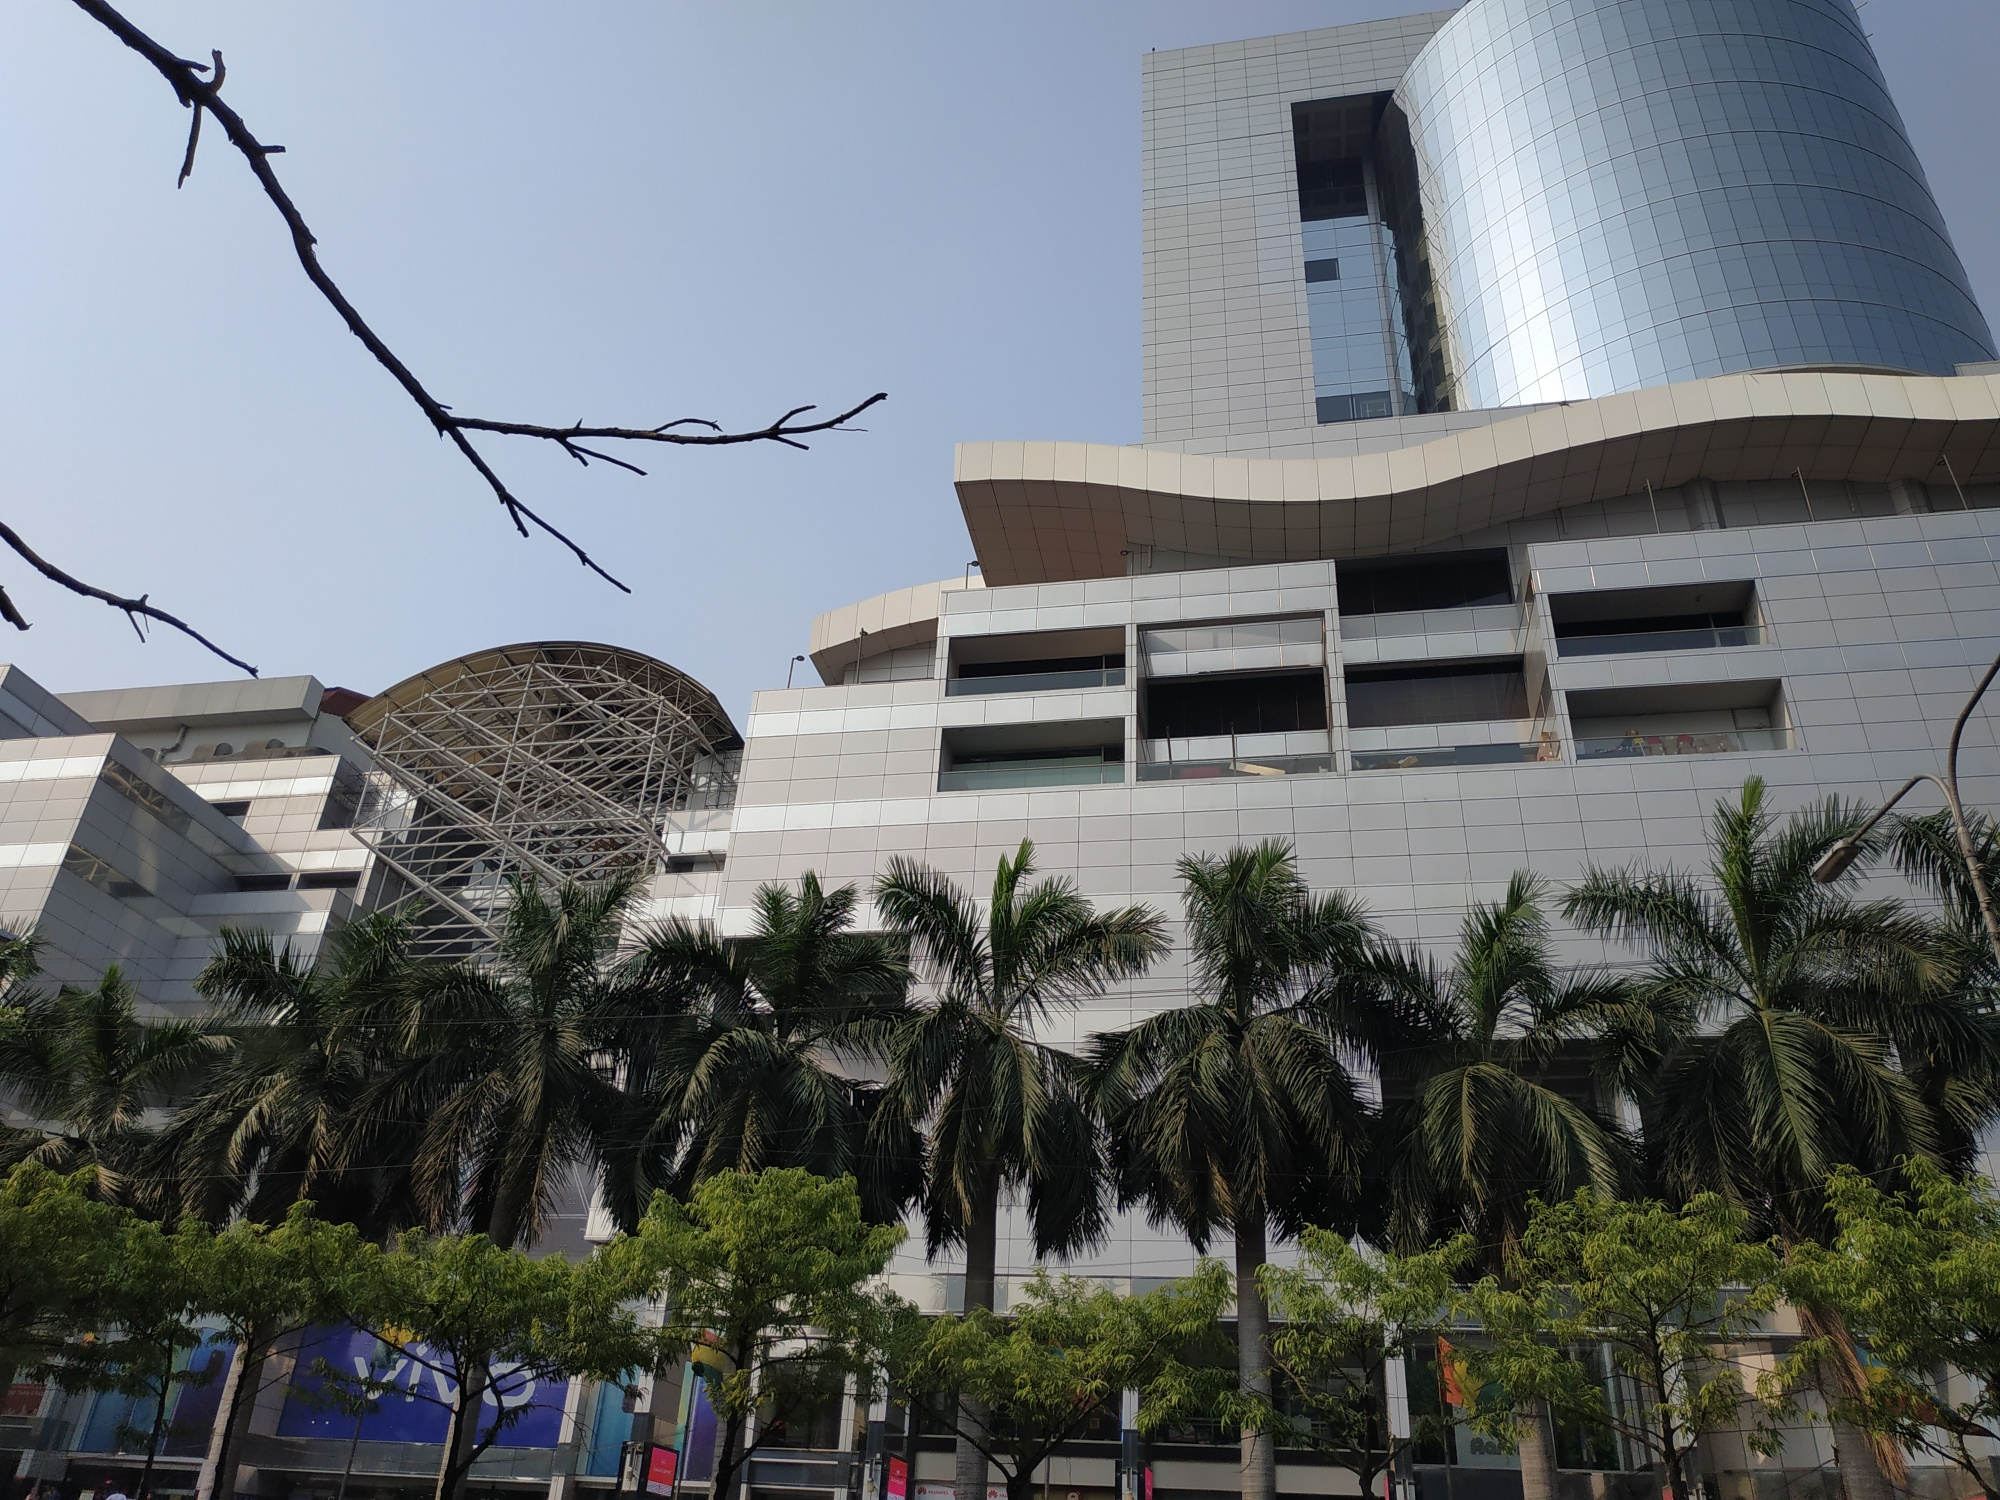Given the image, what might be happening in the surroundings of this building at night? At night, the area around this striking building transforms completely. The facade of the building is illuminated with colorful, dynamic lights that create a mesmerizing display, attracting both tourists and locals. The glass surfaces reflect the vibrant city lights, creating a dazzling effect. Street performers and small vendors set up stalls along the sidewalks, adding life and energy to the scene. The palm trees are wrapped with twinkling fairy lights, giving the entire area a festive vibe. Cafes and restaurants nearby are bustling with people enjoying late-night meals and drinks. It’s a lively urban environment where the community gathers to unwind and enjoy the city’s nightlife against the backdrop of this iconic architectural marvel. 